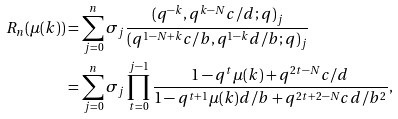<formula> <loc_0><loc_0><loc_500><loc_500>R _ { n } ( \mu ( k ) ) & = \sum _ { j = 0 } ^ { n } \sigma _ { j } \frac { ( q ^ { - k } , q ^ { k - N } c / d ; q ) _ { j } } { ( q ^ { 1 - N + k } c / b , q ^ { 1 - k } d / b ; q ) _ { j } } \\ & = \sum _ { j = 0 } ^ { n } \sigma _ { j } \prod _ { t = 0 } ^ { j - 1 } \frac { 1 - q ^ { t } \mu ( k ) + q ^ { 2 t - N } c / d } { 1 - q ^ { t + 1 } \mu ( k ) d / b + q ^ { 2 t + 2 - N } c d / b ^ { 2 } } ,</formula> 